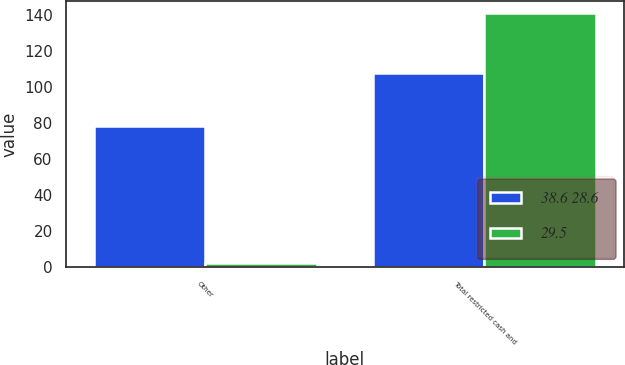Convert chart. <chart><loc_0><loc_0><loc_500><loc_500><stacked_bar_chart><ecel><fcel>Other<fcel>Total restricted cash and<nl><fcel>38.6 28.6<fcel>78.6<fcel>108.1<nl><fcel>29.5<fcel>2.5<fcel>141.1<nl></chart> 